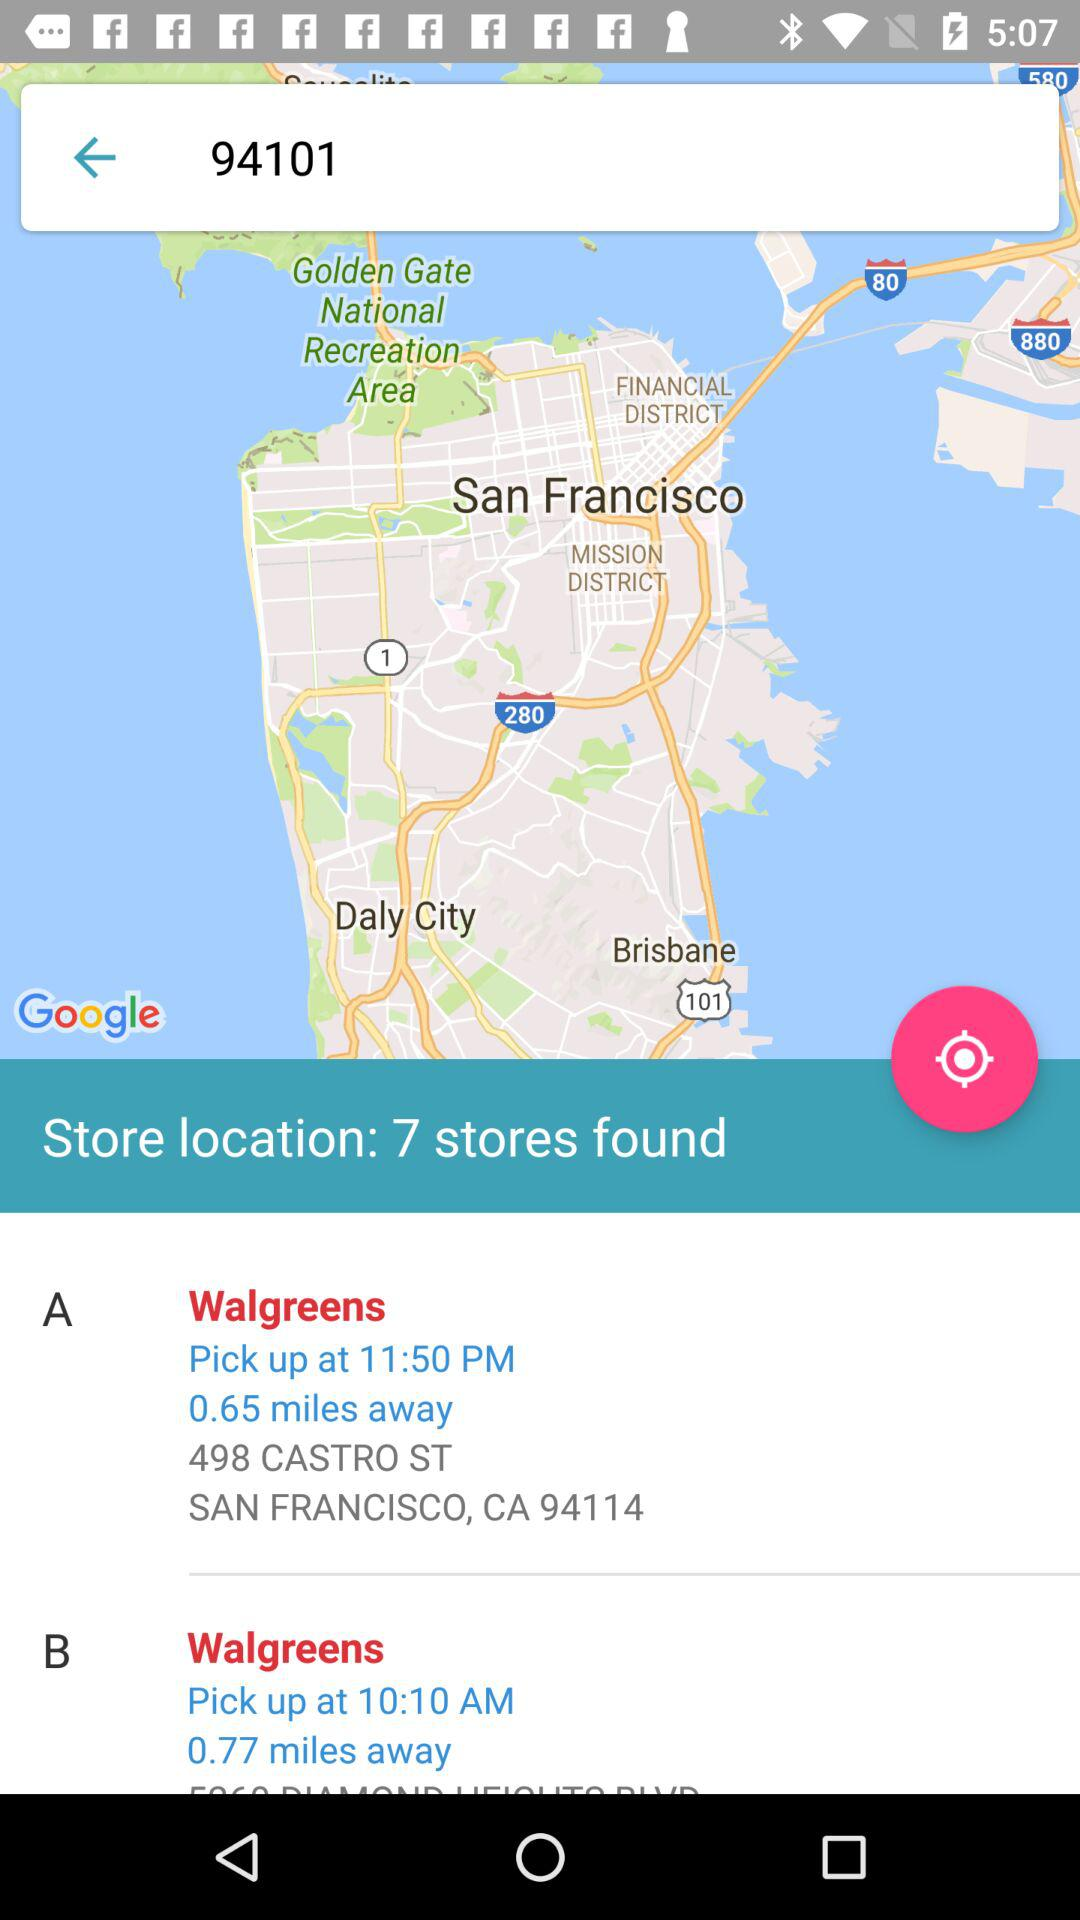How many stores are found there? There are 7 stores found. 